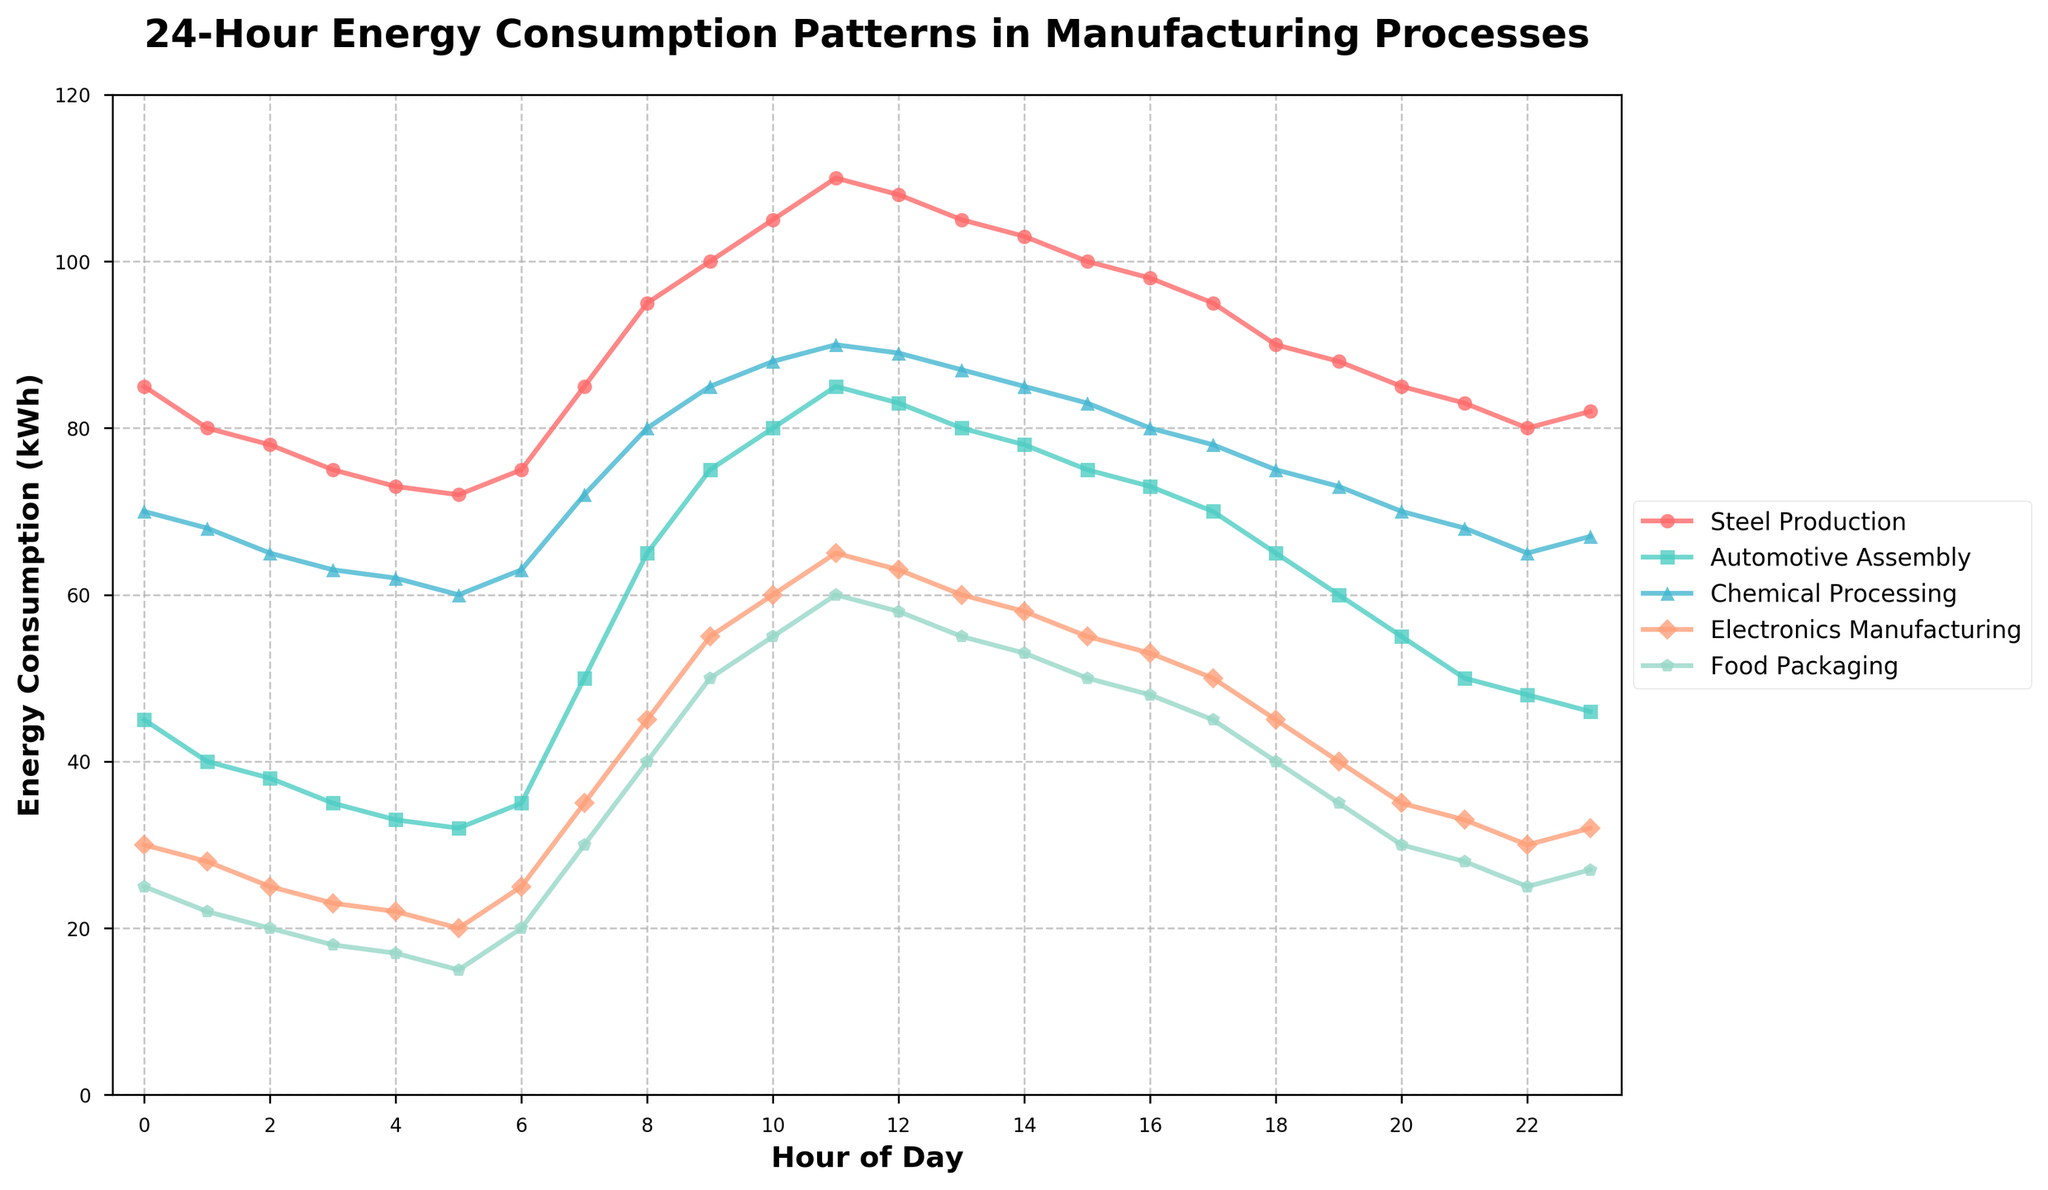What is the peak energy consumption for Steel Production, and at what hour does it occur? First, locate the line representing Steel Production, which is marked by specific colored markers. Next, find the highest point of the line, which exhibits the peak energy consumption. Check the corresponding hour on the x-axis for this peak.
Answer: 110 kWh at Hour 11 Which manufacturing process has the lowest energy consumption at 5 AM? Find the data points for each manufacturing process at Hour 5 on the x-axis. Compare the y-values (energy consumption) of all these points and identify the lowest one.
Answer: Food Packaging At what hours does Chemical Processing show exactly 85 kWh of energy consumption? Trace the line representing Chemical Processing and locate the points where it intersects the 85 kWh mark on the y-axis. Identify the corresponding hours on the x-axis.
Answer: Hour 9 and Hour 14 Which manufacturing process shows the most rapid increase in energy consumption between 6 AM and 8 AM? For each process, calculate the difference in energy consumption between Hour 6 and Hour 8. Compare these differences and identify the process with the largest increase.
Answer: Automotive Assembly At what hour does Electronics Manufacturing show its minimum energy consumption, and what is the value? Follow the Electronics Manufacturing line to find the lowest point. Check the corresponding hour and y-value.
Answer: 18 kWh at Hour 4 How does the energy consumption of Food Packaging at 6 PM compare to that of Electronics Manufacturing at the same hour? Locate the data points for both Food Packaging and Electronics Manufacturing at Hour 18 on the x-axis. Compare their y-values (energy consumption).
Answer: Electronics Manufacturing is 45 kWh, and Food Packaging is 40 kWh; Electronics Manufacturing is higher Which process shows the smallest variation in energy consumption throughout the 24-hour period? Calculate the difference between the maximum and minimum energy consumption for each process over the 24-hour period. The process with the smallest difference is the one with the least variation.
Answer: Food Packaging How does the average energy consumption of Automotive Assembly compare to Chemical Processing over the entire day? Calculate the average energy consumption for both Automotive Assembly and Chemical Processing by summing up their respective hourly values and dividing by 24 (the total number of hours). Compare these averages.
Answer: Automotive Assembly: 59.25 kWh, Chemical Processing: 74.29 kWh; Chemical Processing is higher Which hour exhibits the largest drop in energy consumption for Steel Production, and what is the magnitude of this drop? Monitor the line for Steel Production and determine the hour-to-hour differences. Identify the largest negative difference and the corresponding hour range.
Answer: The largest drop is from Hour 11 to Hour 12; the drop is 110 kWh - 108 kWh = 2 kWh Which two manufacturing processes have identical energy consumption at any given hour, and what is that hour? Compare the lines of all manufacturing processes throughout 24 hours and find any overlapping points with equal y-values. Identify the hour at which this happens.
Answer: Steel Production and Chemical Processing at Hour 23, both are at 82 kWh 